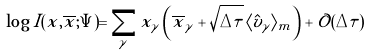<formula> <loc_0><loc_0><loc_500><loc_500>\log I ( { x } , \overline { x } ; \Psi ) = \sum _ { \gamma } x _ { \gamma } \left ( \overline { x } _ { \gamma } + \sqrt { \Delta \tau } \, \langle \hat { v } _ { \gamma } \rangle _ { m } \right ) + \mathcal { O } ( \Delta \tau )</formula> 